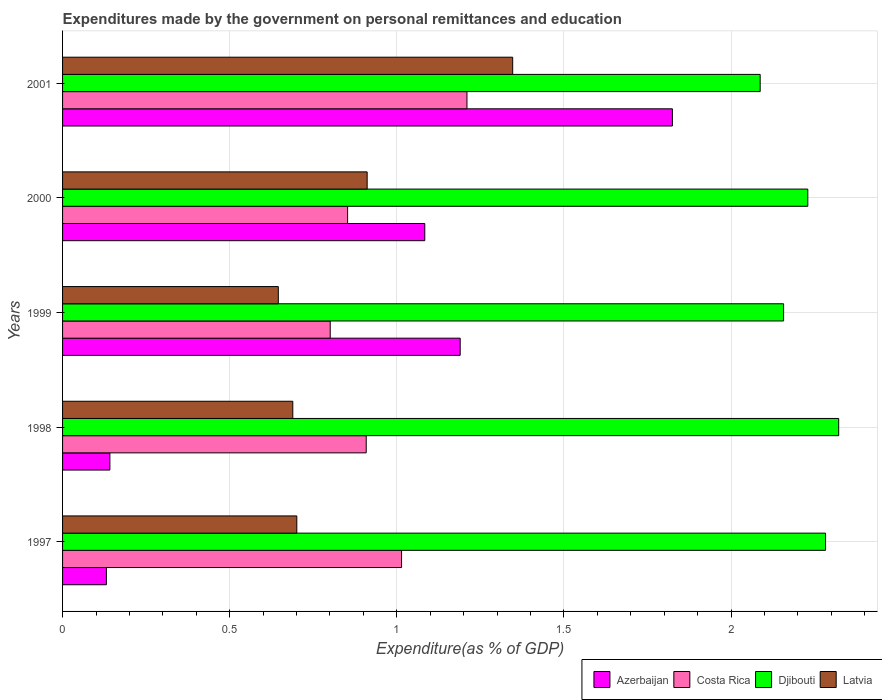What is the expenditures made by the government on personal remittances and education in Costa Rica in 1997?
Keep it short and to the point. 1.01. Across all years, what is the maximum expenditures made by the government on personal remittances and education in Djibouti?
Give a very brief answer. 2.32. Across all years, what is the minimum expenditures made by the government on personal remittances and education in Djibouti?
Your response must be concise. 2.09. What is the total expenditures made by the government on personal remittances and education in Azerbaijan in the graph?
Your answer should be very brief. 4.37. What is the difference between the expenditures made by the government on personal remittances and education in Latvia in 1997 and that in 1999?
Your answer should be very brief. 0.06. What is the difference between the expenditures made by the government on personal remittances and education in Costa Rica in 2001 and the expenditures made by the government on personal remittances and education in Djibouti in 1999?
Offer a very short reply. -0.95. What is the average expenditures made by the government on personal remittances and education in Costa Rica per year?
Offer a terse response. 0.96. In the year 1997, what is the difference between the expenditures made by the government on personal remittances and education in Costa Rica and expenditures made by the government on personal remittances and education in Azerbaijan?
Your answer should be very brief. 0.88. What is the ratio of the expenditures made by the government on personal remittances and education in Latvia in 1997 to that in 1999?
Keep it short and to the point. 1.09. What is the difference between the highest and the second highest expenditures made by the government on personal remittances and education in Costa Rica?
Provide a short and direct response. 0.2. What is the difference between the highest and the lowest expenditures made by the government on personal remittances and education in Djibouti?
Provide a succinct answer. 0.23. In how many years, is the expenditures made by the government on personal remittances and education in Djibouti greater than the average expenditures made by the government on personal remittances and education in Djibouti taken over all years?
Offer a very short reply. 3. Is the sum of the expenditures made by the government on personal remittances and education in Djibouti in 1997 and 2000 greater than the maximum expenditures made by the government on personal remittances and education in Azerbaijan across all years?
Offer a very short reply. Yes. What does the 4th bar from the top in 1997 represents?
Your answer should be very brief. Azerbaijan. What does the 3rd bar from the bottom in 1997 represents?
Offer a terse response. Djibouti. How many bars are there?
Keep it short and to the point. 20. Are all the bars in the graph horizontal?
Your answer should be compact. Yes. How many years are there in the graph?
Make the answer very short. 5. What is the difference between two consecutive major ticks on the X-axis?
Provide a short and direct response. 0.5. Does the graph contain any zero values?
Keep it short and to the point. No. Does the graph contain grids?
Your answer should be very brief. Yes. How many legend labels are there?
Keep it short and to the point. 4. What is the title of the graph?
Provide a succinct answer. Expenditures made by the government on personal remittances and education. Does "Sint Maarten (Dutch part)" appear as one of the legend labels in the graph?
Keep it short and to the point. No. What is the label or title of the X-axis?
Make the answer very short. Expenditure(as % of GDP). What is the Expenditure(as % of GDP) of Azerbaijan in 1997?
Provide a succinct answer. 0.13. What is the Expenditure(as % of GDP) in Costa Rica in 1997?
Your answer should be compact. 1.01. What is the Expenditure(as % of GDP) of Djibouti in 1997?
Make the answer very short. 2.28. What is the Expenditure(as % of GDP) of Latvia in 1997?
Your answer should be compact. 0.7. What is the Expenditure(as % of GDP) in Azerbaijan in 1998?
Provide a succinct answer. 0.14. What is the Expenditure(as % of GDP) in Costa Rica in 1998?
Offer a terse response. 0.91. What is the Expenditure(as % of GDP) in Djibouti in 1998?
Offer a terse response. 2.32. What is the Expenditure(as % of GDP) of Latvia in 1998?
Your response must be concise. 0.69. What is the Expenditure(as % of GDP) in Azerbaijan in 1999?
Your answer should be very brief. 1.19. What is the Expenditure(as % of GDP) in Costa Rica in 1999?
Keep it short and to the point. 0.8. What is the Expenditure(as % of GDP) in Djibouti in 1999?
Provide a short and direct response. 2.16. What is the Expenditure(as % of GDP) of Latvia in 1999?
Ensure brevity in your answer.  0.65. What is the Expenditure(as % of GDP) of Azerbaijan in 2000?
Your response must be concise. 1.08. What is the Expenditure(as % of GDP) of Costa Rica in 2000?
Make the answer very short. 0.85. What is the Expenditure(as % of GDP) in Djibouti in 2000?
Your answer should be compact. 2.23. What is the Expenditure(as % of GDP) of Latvia in 2000?
Ensure brevity in your answer.  0.91. What is the Expenditure(as % of GDP) in Azerbaijan in 2001?
Make the answer very short. 1.82. What is the Expenditure(as % of GDP) of Costa Rica in 2001?
Make the answer very short. 1.21. What is the Expenditure(as % of GDP) in Djibouti in 2001?
Provide a succinct answer. 2.09. What is the Expenditure(as % of GDP) of Latvia in 2001?
Give a very brief answer. 1.35. Across all years, what is the maximum Expenditure(as % of GDP) of Azerbaijan?
Your answer should be compact. 1.82. Across all years, what is the maximum Expenditure(as % of GDP) of Costa Rica?
Your response must be concise. 1.21. Across all years, what is the maximum Expenditure(as % of GDP) in Djibouti?
Offer a terse response. 2.32. Across all years, what is the maximum Expenditure(as % of GDP) in Latvia?
Give a very brief answer. 1.35. Across all years, what is the minimum Expenditure(as % of GDP) in Azerbaijan?
Offer a very short reply. 0.13. Across all years, what is the minimum Expenditure(as % of GDP) in Costa Rica?
Give a very brief answer. 0.8. Across all years, what is the minimum Expenditure(as % of GDP) in Djibouti?
Give a very brief answer. 2.09. Across all years, what is the minimum Expenditure(as % of GDP) of Latvia?
Offer a very short reply. 0.65. What is the total Expenditure(as % of GDP) in Azerbaijan in the graph?
Provide a succinct answer. 4.37. What is the total Expenditure(as % of GDP) in Costa Rica in the graph?
Your response must be concise. 4.79. What is the total Expenditure(as % of GDP) of Djibouti in the graph?
Provide a succinct answer. 11.08. What is the total Expenditure(as % of GDP) in Latvia in the graph?
Ensure brevity in your answer.  4.29. What is the difference between the Expenditure(as % of GDP) of Azerbaijan in 1997 and that in 1998?
Your answer should be very brief. -0.01. What is the difference between the Expenditure(as % of GDP) in Costa Rica in 1997 and that in 1998?
Your response must be concise. 0.11. What is the difference between the Expenditure(as % of GDP) in Djibouti in 1997 and that in 1998?
Offer a terse response. -0.04. What is the difference between the Expenditure(as % of GDP) in Latvia in 1997 and that in 1998?
Ensure brevity in your answer.  0.01. What is the difference between the Expenditure(as % of GDP) of Azerbaijan in 1997 and that in 1999?
Keep it short and to the point. -1.06. What is the difference between the Expenditure(as % of GDP) of Costa Rica in 1997 and that in 1999?
Give a very brief answer. 0.21. What is the difference between the Expenditure(as % of GDP) in Djibouti in 1997 and that in 1999?
Offer a terse response. 0.13. What is the difference between the Expenditure(as % of GDP) of Latvia in 1997 and that in 1999?
Provide a short and direct response. 0.06. What is the difference between the Expenditure(as % of GDP) of Azerbaijan in 1997 and that in 2000?
Provide a short and direct response. -0.95. What is the difference between the Expenditure(as % of GDP) of Costa Rica in 1997 and that in 2000?
Make the answer very short. 0.16. What is the difference between the Expenditure(as % of GDP) in Djibouti in 1997 and that in 2000?
Your answer should be very brief. 0.05. What is the difference between the Expenditure(as % of GDP) in Latvia in 1997 and that in 2000?
Ensure brevity in your answer.  -0.21. What is the difference between the Expenditure(as % of GDP) in Azerbaijan in 1997 and that in 2001?
Offer a terse response. -1.69. What is the difference between the Expenditure(as % of GDP) in Costa Rica in 1997 and that in 2001?
Ensure brevity in your answer.  -0.2. What is the difference between the Expenditure(as % of GDP) in Djibouti in 1997 and that in 2001?
Your response must be concise. 0.2. What is the difference between the Expenditure(as % of GDP) of Latvia in 1997 and that in 2001?
Make the answer very short. -0.65. What is the difference between the Expenditure(as % of GDP) in Azerbaijan in 1998 and that in 1999?
Your answer should be compact. -1.05. What is the difference between the Expenditure(as % of GDP) in Costa Rica in 1998 and that in 1999?
Ensure brevity in your answer.  0.11. What is the difference between the Expenditure(as % of GDP) of Djibouti in 1998 and that in 1999?
Provide a short and direct response. 0.16. What is the difference between the Expenditure(as % of GDP) of Latvia in 1998 and that in 1999?
Provide a succinct answer. 0.04. What is the difference between the Expenditure(as % of GDP) of Azerbaijan in 1998 and that in 2000?
Offer a terse response. -0.94. What is the difference between the Expenditure(as % of GDP) of Costa Rica in 1998 and that in 2000?
Provide a succinct answer. 0.06. What is the difference between the Expenditure(as % of GDP) of Djibouti in 1998 and that in 2000?
Your answer should be compact. 0.09. What is the difference between the Expenditure(as % of GDP) of Latvia in 1998 and that in 2000?
Offer a terse response. -0.22. What is the difference between the Expenditure(as % of GDP) in Azerbaijan in 1998 and that in 2001?
Make the answer very short. -1.68. What is the difference between the Expenditure(as % of GDP) of Costa Rica in 1998 and that in 2001?
Make the answer very short. -0.3. What is the difference between the Expenditure(as % of GDP) in Djibouti in 1998 and that in 2001?
Provide a short and direct response. 0.23. What is the difference between the Expenditure(as % of GDP) of Latvia in 1998 and that in 2001?
Your response must be concise. -0.66. What is the difference between the Expenditure(as % of GDP) in Azerbaijan in 1999 and that in 2000?
Provide a short and direct response. 0.11. What is the difference between the Expenditure(as % of GDP) in Costa Rica in 1999 and that in 2000?
Offer a terse response. -0.05. What is the difference between the Expenditure(as % of GDP) of Djibouti in 1999 and that in 2000?
Offer a terse response. -0.07. What is the difference between the Expenditure(as % of GDP) of Latvia in 1999 and that in 2000?
Keep it short and to the point. -0.27. What is the difference between the Expenditure(as % of GDP) of Azerbaijan in 1999 and that in 2001?
Your response must be concise. -0.63. What is the difference between the Expenditure(as % of GDP) of Costa Rica in 1999 and that in 2001?
Your answer should be very brief. -0.41. What is the difference between the Expenditure(as % of GDP) of Djibouti in 1999 and that in 2001?
Give a very brief answer. 0.07. What is the difference between the Expenditure(as % of GDP) in Latvia in 1999 and that in 2001?
Offer a very short reply. -0.7. What is the difference between the Expenditure(as % of GDP) in Azerbaijan in 2000 and that in 2001?
Give a very brief answer. -0.74. What is the difference between the Expenditure(as % of GDP) of Costa Rica in 2000 and that in 2001?
Provide a short and direct response. -0.36. What is the difference between the Expenditure(as % of GDP) in Djibouti in 2000 and that in 2001?
Make the answer very short. 0.14. What is the difference between the Expenditure(as % of GDP) in Latvia in 2000 and that in 2001?
Make the answer very short. -0.44. What is the difference between the Expenditure(as % of GDP) of Azerbaijan in 1997 and the Expenditure(as % of GDP) of Costa Rica in 1998?
Your answer should be compact. -0.78. What is the difference between the Expenditure(as % of GDP) in Azerbaijan in 1997 and the Expenditure(as % of GDP) in Djibouti in 1998?
Your answer should be compact. -2.19. What is the difference between the Expenditure(as % of GDP) of Azerbaijan in 1997 and the Expenditure(as % of GDP) of Latvia in 1998?
Offer a very short reply. -0.56. What is the difference between the Expenditure(as % of GDP) of Costa Rica in 1997 and the Expenditure(as % of GDP) of Djibouti in 1998?
Give a very brief answer. -1.31. What is the difference between the Expenditure(as % of GDP) in Costa Rica in 1997 and the Expenditure(as % of GDP) in Latvia in 1998?
Keep it short and to the point. 0.33. What is the difference between the Expenditure(as % of GDP) of Djibouti in 1997 and the Expenditure(as % of GDP) of Latvia in 1998?
Your answer should be very brief. 1.59. What is the difference between the Expenditure(as % of GDP) of Azerbaijan in 1997 and the Expenditure(as % of GDP) of Costa Rica in 1999?
Offer a very short reply. -0.67. What is the difference between the Expenditure(as % of GDP) of Azerbaijan in 1997 and the Expenditure(as % of GDP) of Djibouti in 1999?
Offer a terse response. -2.03. What is the difference between the Expenditure(as % of GDP) of Azerbaijan in 1997 and the Expenditure(as % of GDP) of Latvia in 1999?
Your response must be concise. -0.51. What is the difference between the Expenditure(as % of GDP) in Costa Rica in 1997 and the Expenditure(as % of GDP) in Djibouti in 1999?
Provide a succinct answer. -1.14. What is the difference between the Expenditure(as % of GDP) of Costa Rica in 1997 and the Expenditure(as % of GDP) of Latvia in 1999?
Provide a succinct answer. 0.37. What is the difference between the Expenditure(as % of GDP) of Djibouti in 1997 and the Expenditure(as % of GDP) of Latvia in 1999?
Your answer should be very brief. 1.64. What is the difference between the Expenditure(as % of GDP) in Azerbaijan in 1997 and the Expenditure(as % of GDP) in Costa Rica in 2000?
Give a very brief answer. -0.72. What is the difference between the Expenditure(as % of GDP) of Azerbaijan in 1997 and the Expenditure(as % of GDP) of Djibouti in 2000?
Offer a terse response. -2.1. What is the difference between the Expenditure(as % of GDP) of Azerbaijan in 1997 and the Expenditure(as % of GDP) of Latvia in 2000?
Offer a very short reply. -0.78. What is the difference between the Expenditure(as % of GDP) in Costa Rica in 1997 and the Expenditure(as % of GDP) in Djibouti in 2000?
Your response must be concise. -1.22. What is the difference between the Expenditure(as % of GDP) in Costa Rica in 1997 and the Expenditure(as % of GDP) in Latvia in 2000?
Offer a terse response. 0.1. What is the difference between the Expenditure(as % of GDP) of Djibouti in 1997 and the Expenditure(as % of GDP) of Latvia in 2000?
Make the answer very short. 1.37. What is the difference between the Expenditure(as % of GDP) in Azerbaijan in 1997 and the Expenditure(as % of GDP) in Costa Rica in 2001?
Provide a short and direct response. -1.08. What is the difference between the Expenditure(as % of GDP) of Azerbaijan in 1997 and the Expenditure(as % of GDP) of Djibouti in 2001?
Keep it short and to the point. -1.96. What is the difference between the Expenditure(as % of GDP) of Azerbaijan in 1997 and the Expenditure(as % of GDP) of Latvia in 2001?
Your response must be concise. -1.22. What is the difference between the Expenditure(as % of GDP) of Costa Rica in 1997 and the Expenditure(as % of GDP) of Djibouti in 2001?
Make the answer very short. -1.07. What is the difference between the Expenditure(as % of GDP) of Costa Rica in 1997 and the Expenditure(as % of GDP) of Latvia in 2001?
Give a very brief answer. -0.33. What is the difference between the Expenditure(as % of GDP) in Djibouti in 1997 and the Expenditure(as % of GDP) in Latvia in 2001?
Keep it short and to the point. 0.94. What is the difference between the Expenditure(as % of GDP) of Azerbaijan in 1998 and the Expenditure(as % of GDP) of Costa Rica in 1999?
Keep it short and to the point. -0.66. What is the difference between the Expenditure(as % of GDP) of Azerbaijan in 1998 and the Expenditure(as % of GDP) of Djibouti in 1999?
Ensure brevity in your answer.  -2.02. What is the difference between the Expenditure(as % of GDP) of Azerbaijan in 1998 and the Expenditure(as % of GDP) of Latvia in 1999?
Your answer should be compact. -0.5. What is the difference between the Expenditure(as % of GDP) of Costa Rica in 1998 and the Expenditure(as % of GDP) of Djibouti in 1999?
Make the answer very short. -1.25. What is the difference between the Expenditure(as % of GDP) in Costa Rica in 1998 and the Expenditure(as % of GDP) in Latvia in 1999?
Give a very brief answer. 0.26. What is the difference between the Expenditure(as % of GDP) of Djibouti in 1998 and the Expenditure(as % of GDP) of Latvia in 1999?
Offer a terse response. 1.68. What is the difference between the Expenditure(as % of GDP) in Azerbaijan in 1998 and the Expenditure(as % of GDP) in Costa Rica in 2000?
Offer a very short reply. -0.71. What is the difference between the Expenditure(as % of GDP) in Azerbaijan in 1998 and the Expenditure(as % of GDP) in Djibouti in 2000?
Offer a very short reply. -2.09. What is the difference between the Expenditure(as % of GDP) in Azerbaijan in 1998 and the Expenditure(as % of GDP) in Latvia in 2000?
Your answer should be very brief. -0.77. What is the difference between the Expenditure(as % of GDP) in Costa Rica in 1998 and the Expenditure(as % of GDP) in Djibouti in 2000?
Make the answer very short. -1.32. What is the difference between the Expenditure(as % of GDP) of Costa Rica in 1998 and the Expenditure(as % of GDP) of Latvia in 2000?
Your response must be concise. -0. What is the difference between the Expenditure(as % of GDP) in Djibouti in 1998 and the Expenditure(as % of GDP) in Latvia in 2000?
Your answer should be very brief. 1.41. What is the difference between the Expenditure(as % of GDP) in Azerbaijan in 1998 and the Expenditure(as % of GDP) in Costa Rica in 2001?
Ensure brevity in your answer.  -1.07. What is the difference between the Expenditure(as % of GDP) in Azerbaijan in 1998 and the Expenditure(as % of GDP) in Djibouti in 2001?
Give a very brief answer. -1.95. What is the difference between the Expenditure(as % of GDP) of Azerbaijan in 1998 and the Expenditure(as % of GDP) of Latvia in 2001?
Offer a very short reply. -1.21. What is the difference between the Expenditure(as % of GDP) of Costa Rica in 1998 and the Expenditure(as % of GDP) of Djibouti in 2001?
Ensure brevity in your answer.  -1.18. What is the difference between the Expenditure(as % of GDP) in Costa Rica in 1998 and the Expenditure(as % of GDP) in Latvia in 2001?
Your answer should be compact. -0.44. What is the difference between the Expenditure(as % of GDP) of Djibouti in 1998 and the Expenditure(as % of GDP) of Latvia in 2001?
Keep it short and to the point. 0.98. What is the difference between the Expenditure(as % of GDP) of Azerbaijan in 1999 and the Expenditure(as % of GDP) of Costa Rica in 2000?
Keep it short and to the point. 0.34. What is the difference between the Expenditure(as % of GDP) of Azerbaijan in 1999 and the Expenditure(as % of GDP) of Djibouti in 2000?
Offer a terse response. -1.04. What is the difference between the Expenditure(as % of GDP) in Azerbaijan in 1999 and the Expenditure(as % of GDP) in Latvia in 2000?
Offer a very short reply. 0.28. What is the difference between the Expenditure(as % of GDP) in Costa Rica in 1999 and the Expenditure(as % of GDP) in Djibouti in 2000?
Offer a terse response. -1.43. What is the difference between the Expenditure(as % of GDP) of Costa Rica in 1999 and the Expenditure(as % of GDP) of Latvia in 2000?
Your answer should be very brief. -0.11. What is the difference between the Expenditure(as % of GDP) of Djibouti in 1999 and the Expenditure(as % of GDP) of Latvia in 2000?
Ensure brevity in your answer.  1.25. What is the difference between the Expenditure(as % of GDP) of Azerbaijan in 1999 and the Expenditure(as % of GDP) of Costa Rica in 2001?
Your answer should be compact. -0.02. What is the difference between the Expenditure(as % of GDP) in Azerbaijan in 1999 and the Expenditure(as % of GDP) in Djibouti in 2001?
Give a very brief answer. -0.9. What is the difference between the Expenditure(as % of GDP) in Azerbaijan in 1999 and the Expenditure(as % of GDP) in Latvia in 2001?
Make the answer very short. -0.16. What is the difference between the Expenditure(as % of GDP) of Costa Rica in 1999 and the Expenditure(as % of GDP) of Djibouti in 2001?
Your answer should be compact. -1.29. What is the difference between the Expenditure(as % of GDP) in Costa Rica in 1999 and the Expenditure(as % of GDP) in Latvia in 2001?
Provide a succinct answer. -0.55. What is the difference between the Expenditure(as % of GDP) in Djibouti in 1999 and the Expenditure(as % of GDP) in Latvia in 2001?
Your answer should be compact. 0.81. What is the difference between the Expenditure(as % of GDP) in Azerbaijan in 2000 and the Expenditure(as % of GDP) in Costa Rica in 2001?
Ensure brevity in your answer.  -0.13. What is the difference between the Expenditure(as % of GDP) of Azerbaijan in 2000 and the Expenditure(as % of GDP) of Djibouti in 2001?
Give a very brief answer. -1. What is the difference between the Expenditure(as % of GDP) in Azerbaijan in 2000 and the Expenditure(as % of GDP) in Latvia in 2001?
Give a very brief answer. -0.26. What is the difference between the Expenditure(as % of GDP) of Costa Rica in 2000 and the Expenditure(as % of GDP) of Djibouti in 2001?
Ensure brevity in your answer.  -1.23. What is the difference between the Expenditure(as % of GDP) in Costa Rica in 2000 and the Expenditure(as % of GDP) in Latvia in 2001?
Your answer should be compact. -0.49. What is the difference between the Expenditure(as % of GDP) in Djibouti in 2000 and the Expenditure(as % of GDP) in Latvia in 2001?
Your answer should be very brief. 0.88. What is the average Expenditure(as % of GDP) in Azerbaijan per year?
Keep it short and to the point. 0.87. What is the average Expenditure(as % of GDP) of Costa Rica per year?
Offer a very short reply. 0.96. What is the average Expenditure(as % of GDP) of Djibouti per year?
Offer a terse response. 2.22. What is the average Expenditure(as % of GDP) in Latvia per year?
Your answer should be compact. 0.86. In the year 1997, what is the difference between the Expenditure(as % of GDP) of Azerbaijan and Expenditure(as % of GDP) of Costa Rica?
Offer a terse response. -0.88. In the year 1997, what is the difference between the Expenditure(as % of GDP) of Azerbaijan and Expenditure(as % of GDP) of Djibouti?
Keep it short and to the point. -2.15. In the year 1997, what is the difference between the Expenditure(as % of GDP) of Azerbaijan and Expenditure(as % of GDP) of Latvia?
Offer a terse response. -0.57. In the year 1997, what is the difference between the Expenditure(as % of GDP) of Costa Rica and Expenditure(as % of GDP) of Djibouti?
Ensure brevity in your answer.  -1.27. In the year 1997, what is the difference between the Expenditure(as % of GDP) in Costa Rica and Expenditure(as % of GDP) in Latvia?
Offer a terse response. 0.31. In the year 1997, what is the difference between the Expenditure(as % of GDP) of Djibouti and Expenditure(as % of GDP) of Latvia?
Provide a short and direct response. 1.58. In the year 1998, what is the difference between the Expenditure(as % of GDP) in Azerbaijan and Expenditure(as % of GDP) in Costa Rica?
Give a very brief answer. -0.77. In the year 1998, what is the difference between the Expenditure(as % of GDP) of Azerbaijan and Expenditure(as % of GDP) of Djibouti?
Keep it short and to the point. -2.18. In the year 1998, what is the difference between the Expenditure(as % of GDP) of Azerbaijan and Expenditure(as % of GDP) of Latvia?
Offer a very short reply. -0.55. In the year 1998, what is the difference between the Expenditure(as % of GDP) of Costa Rica and Expenditure(as % of GDP) of Djibouti?
Offer a very short reply. -1.41. In the year 1998, what is the difference between the Expenditure(as % of GDP) in Costa Rica and Expenditure(as % of GDP) in Latvia?
Your answer should be very brief. 0.22. In the year 1998, what is the difference between the Expenditure(as % of GDP) of Djibouti and Expenditure(as % of GDP) of Latvia?
Your response must be concise. 1.63. In the year 1999, what is the difference between the Expenditure(as % of GDP) of Azerbaijan and Expenditure(as % of GDP) of Costa Rica?
Provide a succinct answer. 0.39. In the year 1999, what is the difference between the Expenditure(as % of GDP) of Azerbaijan and Expenditure(as % of GDP) of Djibouti?
Provide a succinct answer. -0.97. In the year 1999, what is the difference between the Expenditure(as % of GDP) of Azerbaijan and Expenditure(as % of GDP) of Latvia?
Your answer should be very brief. 0.54. In the year 1999, what is the difference between the Expenditure(as % of GDP) in Costa Rica and Expenditure(as % of GDP) in Djibouti?
Give a very brief answer. -1.36. In the year 1999, what is the difference between the Expenditure(as % of GDP) of Costa Rica and Expenditure(as % of GDP) of Latvia?
Offer a terse response. 0.16. In the year 1999, what is the difference between the Expenditure(as % of GDP) in Djibouti and Expenditure(as % of GDP) in Latvia?
Provide a short and direct response. 1.51. In the year 2000, what is the difference between the Expenditure(as % of GDP) in Azerbaijan and Expenditure(as % of GDP) in Costa Rica?
Give a very brief answer. 0.23. In the year 2000, what is the difference between the Expenditure(as % of GDP) in Azerbaijan and Expenditure(as % of GDP) in Djibouti?
Your answer should be compact. -1.15. In the year 2000, what is the difference between the Expenditure(as % of GDP) of Azerbaijan and Expenditure(as % of GDP) of Latvia?
Keep it short and to the point. 0.17. In the year 2000, what is the difference between the Expenditure(as % of GDP) of Costa Rica and Expenditure(as % of GDP) of Djibouti?
Provide a succinct answer. -1.38. In the year 2000, what is the difference between the Expenditure(as % of GDP) of Costa Rica and Expenditure(as % of GDP) of Latvia?
Your answer should be very brief. -0.06. In the year 2000, what is the difference between the Expenditure(as % of GDP) in Djibouti and Expenditure(as % of GDP) in Latvia?
Keep it short and to the point. 1.32. In the year 2001, what is the difference between the Expenditure(as % of GDP) of Azerbaijan and Expenditure(as % of GDP) of Costa Rica?
Keep it short and to the point. 0.61. In the year 2001, what is the difference between the Expenditure(as % of GDP) of Azerbaijan and Expenditure(as % of GDP) of Djibouti?
Offer a terse response. -0.26. In the year 2001, what is the difference between the Expenditure(as % of GDP) in Azerbaijan and Expenditure(as % of GDP) in Latvia?
Provide a succinct answer. 0.48. In the year 2001, what is the difference between the Expenditure(as % of GDP) of Costa Rica and Expenditure(as % of GDP) of Djibouti?
Give a very brief answer. -0.88. In the year 2001, what is the difference between the Expenditure(as % of GDP) of Costa Rica and Expenditure(as % of GDP) of Latvia?
Your answer should be compact. -0.14. In the year 2001, what is the difference between the Expenditure(as % of GDP) of Djibouti and Expenditure(as % of GDP) of Latvia?
Offer a very short reply. 0.74. What is the ratio of the Expenditure(as % of GDP) in Azerbaijan in 1997 to that in 1998?
Your answer should be compact. 0.93. What is the ratio of the Expenditure(as % of GDP) in Costa Rica in 1997 to that in 1998?
Your answer should be very brief. 1.12. What is the ratio of the Expenditure(as % of GDP) in Latvia in 1997 to that in 1998?
Give a very brief answer. 1.02. What is the ratio of the Expenditure(as % of GDP) of Azerbaijan in 1997 to that in 1999?
Make the answer very short. 0.11. What is the ratio of the Expenditure(as % of GDP) in Costa Rica in 1997 to that in 1999?
Offer a terse response. 1.27. What is the ratio of the Expenditure(as % of GDP) of Djibouti in 1997 to that in 1999?
Provide a short and direct response. 1.06. What is the ratio of the Expenditure(as % of GDP) of Latvia in 1997 to that in 1999?
Your answer should be compact. 1.09. What is the ratio of the Expenditure(as % of GDP) of Azerbaijan in 1997 to that in 2000?
Give a very brief answer. 0.12. What is the ratio of the Expenditure(as % of GDP) of Costa Rica in 1997 to that in 2000?
Provide a short and direct response. 1.19. What is the ratio of the Expenditure(as % of GDP) in Djibouti in 1997 to that in 2000?
Give a very brief answer. 1.02. What is the ratio of the Expenditure(as % of GDP) in Latvia in 1997 to that in 2000?
Provide a succinct answer. 0.77. What is the ratio of the Expenditure(as % of GDP) of Azerbaijan in 1997 to that in 2001?
Your answer should be very brief. 0.07. What is the ratio of the Expenditure(as % of GDP) in Costa Rica in 1997 to that in 2001?
Give a very brief answer. 0.84. What is the ratio of the Expenditure(as % of GDP) of Djibouti in 1997 to that in 2001?
Provide a short and direct response. 1.09. What is the ratio of the Expenditure(as % of GDP) of Latvia in 1997 to that in 2001?
Offer a very short reply. 0.52. What is the ratio of the Expenditure(as % of GDP) of Azerbaijan in 1998 to that in 1999?
Give a very brief answer. 0.12. What is the ratio of the Expenditure(as % of GDP) of Costa Rica in 1998 to that in 1999?
Provide a short and direct response. 1.13. What is the ratio of the Expenditure(as % of GDP) of Djibouti in 1998 to that in 1999?
Your response must be concise. 1.08. What is the ratio of the Expenditure(as % of GDP) in Latvia in 1998 to that in 1999?
Make the answer very short. 1.07. What is the ratio of the Expenditure(as % of GDP) in Azerbaijan in 1998 to that in 2000?
Keep it short and to the point. 0.13. What is the ratio of the Expenditure(as % of GDP) of Costa Rica in 1998 to that in 2000?
Provide a short and direct response. 1.07. What is the ratio of the Expenditure(as % of GDP) of Djibouti in 1998 to that in 2000?
Provide a succinct answer. 1.04. What is the ratio of the Expenditure(as % of GDP) in Latvia in 1998 to that in 2000?
Keep it short and to the point. 0.76. What is the ratio of the Expenditure(as % of GDP) in Azerbaijan in 1998 to that in 2001?
Make the answer very short. 0.08. What is the ratio of the Expenditure(as % of GDP) of Costa Rica in 1998 to that in 2001?
Offer a very short reply. 0.75. What is the ratio of the Expenditure(as % of GDP) in Djibouti in 1998 to that in 2001?
Your response must be concise. 1.11. What is the ratio of the Expenditure(as % of GDP) in Latvia in 1998 to that in 2001?
Make the answer very short. 0.51. What is the ratio of the Expenditure(as % of GDP) of Azerbaijan in 1999 to that in 2000?
Make the answer very short. 1.1. What is the ratio of the Expenditure(as % of GDP) in Costa Rica in 1999 to that in 2000?
Keep it short and to the point. 0.94. What is the ratio of the Expenditure(as % of GDP) in Djibouti in 1999 to that in 2000?
Your response must be concise. 0.97. What is the ratio of the Expenditure(as % of GDP) of Latvia in 1999 to that in 2000?
Give a very brief answer. 0.71. What is the ratio of the Expenditure(as % of GDP) in Azerbaijan in 1999 to that in 2001?
Provide a succinct answer. 0.65. What is the ratio of the Expenditure(as % of GDP) in Costa Rica in 1999 to that in 2001?
Provide a short and direct response. 0.66. What is the ratio of the Expenditure(as % of GDP) of Djibouti in 1999 to that in 2001?
Ensure brevity in your answer.  1.03. What is the ratio of the Expenditure(as % of GDP) in Latvia in 1999 to that in 2001?
Offer a very short reply. 0.48. What is the ratio of the Expenditure(as % of GDP) in Azerbaijan in 2000 to that in 2001?
Make the answer very short. 0.59. What is the ratio of the Expenditure(as % of GDP) in Costa Rica in 2000 to that in 2001?
Give a very brief answer. 0.7. What is the ratio of the Expenditure(as % of GDP) of Djibouti in 2000 to that in 2001?
Offer a terse response. 1.07. What is the ratio of the Expenditure(as % of GDP) of Latvia in 2000 to that in 2001?
Your response must be concise. 0.68. What is the difference between the highest and the second highest Expenditure(as % of GDP) of Azerbaijan?
Offer a very short reply. 0.63. What is the difference between the highest and the second highest Expenditure(as % of GDP) in Costa Rica?
Provide a short and direct response. 0.2. What is the difference between the highest and the second highest Expenditure(as % of GDP) of Djibouti?
Your response must be concise. 0.04. What is the difference between the highest and the second highest Expenditure(as % of GDP) in Latvia?
Your response must be concise. 0.44. What is the difference between the highest and the lowest Expenditure(as % of GDP) in Azerbaijan?
Make the answer very short. 1.69. What is the difference between the highest and the lowest Expenditure(as % of GDP) of Costa Rica?
Your answer should be compact. 0.41. What is the difference between the highest and the lowest Expenditure(as % of GDP) in Djibouti?
Keep it short and to the point. 0.23. What is the difference between the highest and the lowest Expenditure(as % of GDP) of Latvia?
Provide a succinct answer. 0.7. 